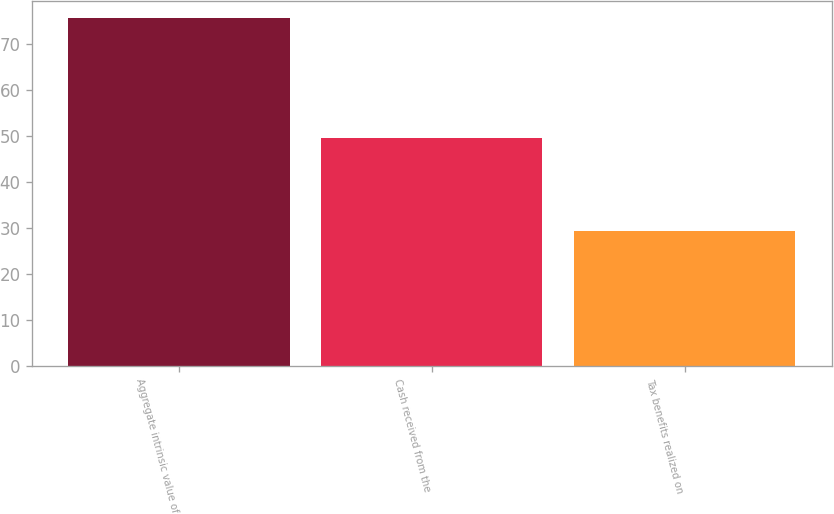<chart> <loc_0><loc_0><loc_500><loc_500><bar_chart><fcel>Aggregate intrinsic value of<fcel>Cash received from the<fcel>Tax benefits realized on<nl><fcel>75.7<fcel>49.6<fcel>29.3<nl></chart> 